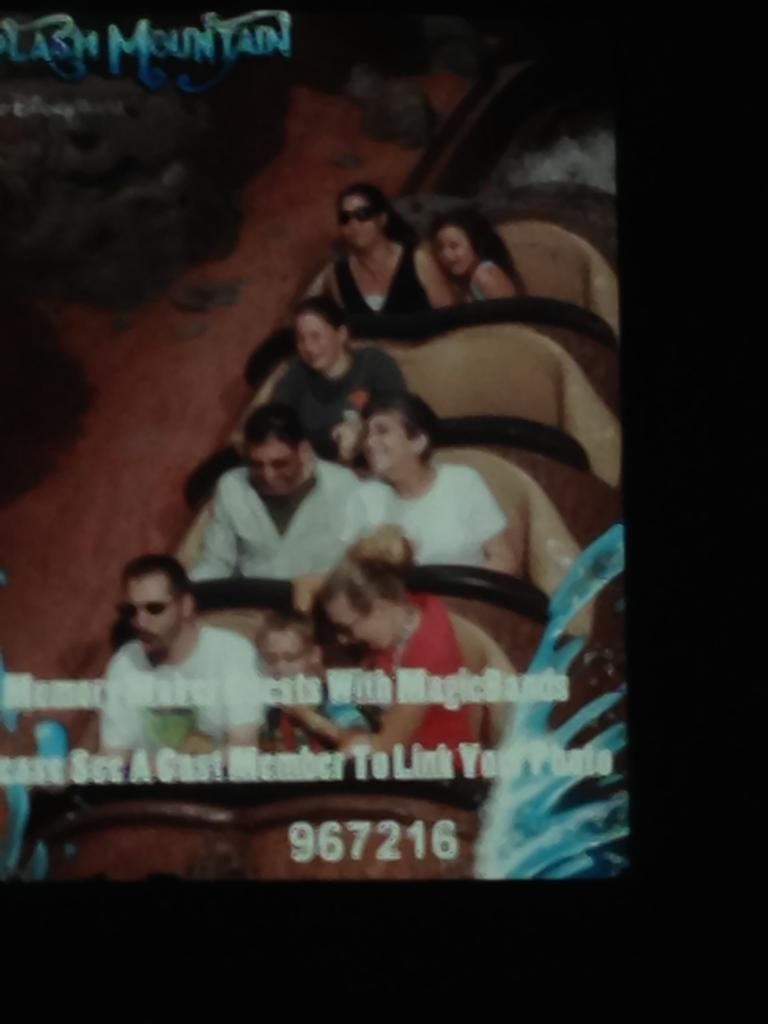What are the people in the image doing? The persons in the image are smiling. How are the persons positioned in the image? The persons are sitting on chairs. What can be seen on the screen in the image? There are texts and numbers on the screen. What is the color of the background in the image? The background of the image is dark in color. Can you tell me how many kitties are sitting on the persons' laps in the image? There are no kitties present in the image. Is the space shuttle visible in the background of the image? There is no space shuttle or any space-related objects present in the image. 